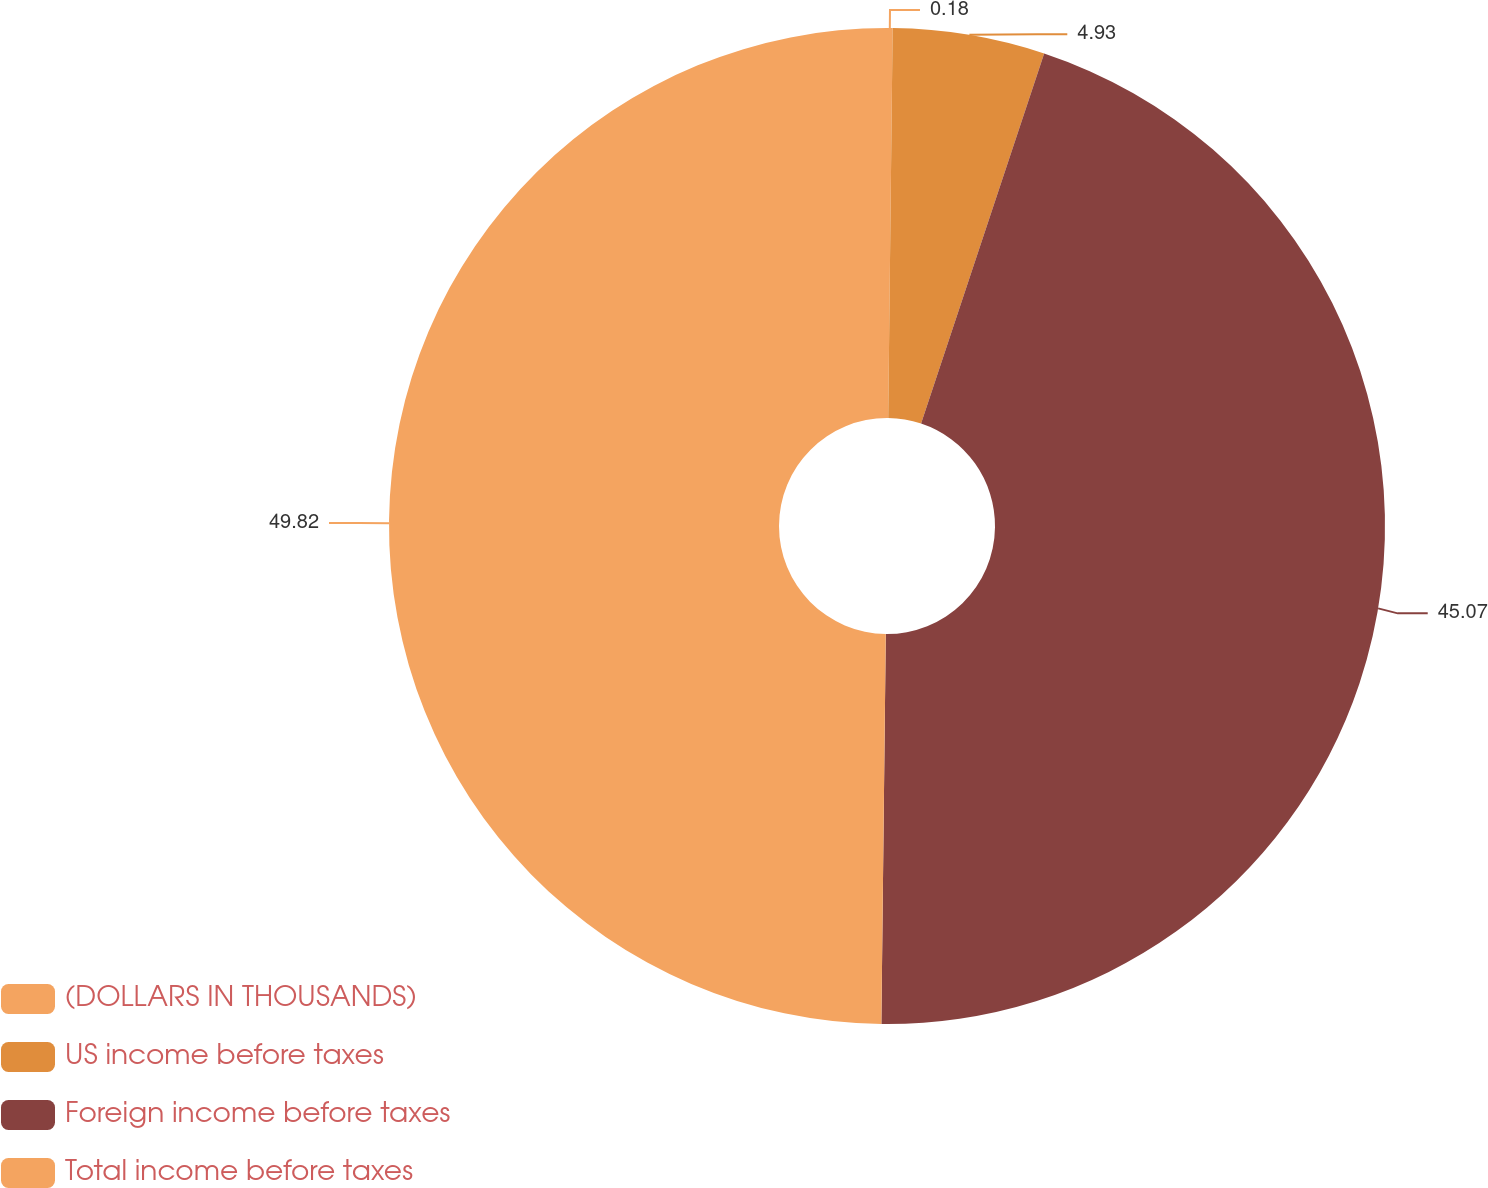Convert chart. <chart><loc_0><loc_0><loc_500><loc_500><pie_chart><fcel>(DOLLARS IN THOUSANDS)<fcel>US income before taxes<fcel>Foreign income before taxes<fcel>Total income before taxes<nl><fcel>0.18%<fcel>4.93%<fcel>45.07%<fcel>49.82%<nl></chart> 